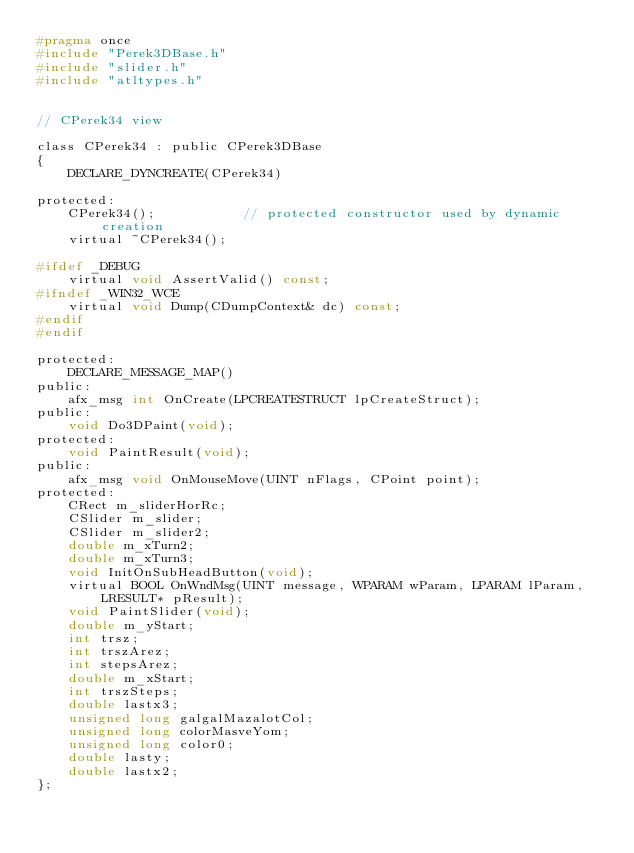<code> <loc_0><loc_0><loc_500><loc_500><_C_>#pragma once
#include "Perek3DBase.h"
#include "slider.h"
#include "atltypes.h"


// CPerek34 view

class CPerek34 : public CPerek3DBase
{
	DECLARE_DYNCREATE(CPerek34)

protected:
	CPerek34();           // protected constructor used by dynamic creation
	virtual ~CPerek34();

#ifdef _DEBUG
	virtual void AssertValid() const;
#ifndef _WIN32_WCE
	virtual void Dump(CDumpContext& dc) const;
#endif
#endif

protected:
	DECLARE_MESSAGE_MAP()
public:
	afx_msg int OnCreate(LPCREATESTRUCT lpCreateStruct);
public:
	void Do3DPaint(void);
protected:
	void PaintResult(void);
public:
	afx_msg void OnMouseMove(UINT nFlags, CPoint point);
protected:
	CRect m_sliderHorRc;
	CSlider m_slider;
	CSlider m_slider2;
	double m_xTurn2;
	double m_xTurn3;
	void InitOnSubHeadButton(void);
	virtual BOOL OnWndMsg(UINT message, WPARAM wParam, LPARAM lParam, LRESULT* pResult);
	void PaintSlider(void);
	double m_yStart;
	int trsz;
	int trszArez;
	int stepsArez;
	double m_xStart;
	int trszSteps;
	double lastx3;
	unsigned long galgalMazalotCol;
	unsigned long colorMasveYom;
	unsigned long color0;
	double lasty;
	double lastx2;
};


</code> 